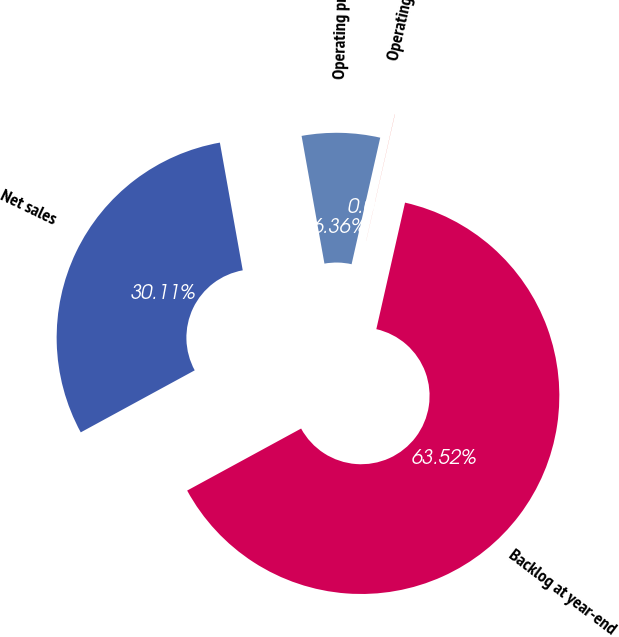<chart> <loc_0><loc_0><loc_500><loc_500><pie_chart><fcel>Net sales<fcel>Operating profit<fcel>Operating margin<fcel>Backlog at year-end<nl><fcel>30.11%<fcel>6.36%<fcel>0.01%<fcel>63.51%<nl></chart> 